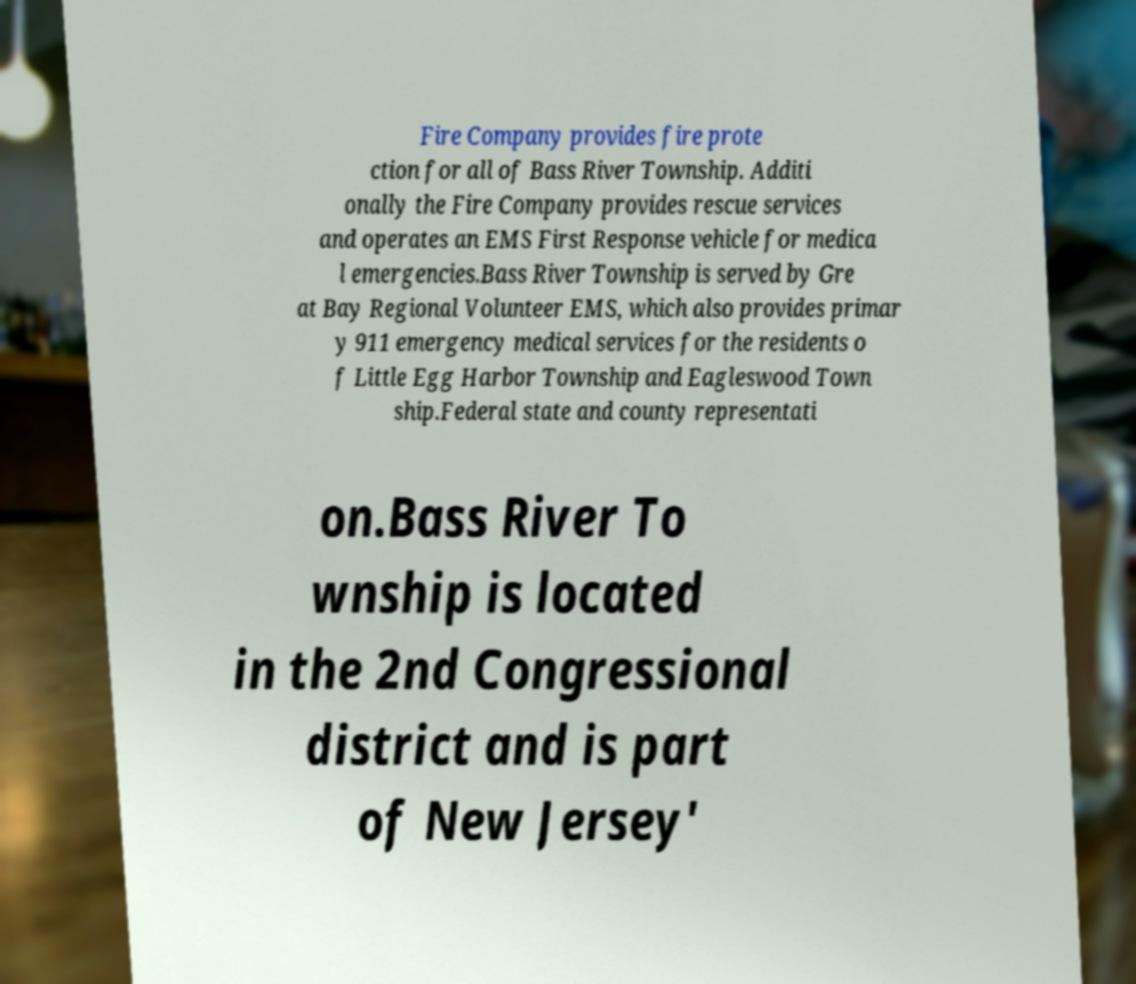Can you read and provide the text displayed in the image?This photo seems to have some interesting text. Can you extract and type it out for me? Fire Company provides fire prote ction for all of Bass River Township. Additi onally the Fire Company provides rescue services and operates an EMS First Response vehicle for medica l emergencies.Bass River Township is served by Gre at Bay Regional Volunteer EMS, which also provides primar y 911 emergency medical services for the residents o f Little Egg Harbor Township and Eagleswood Town ship.Federal state and county representati on.Bass River To wnship is located in the 2nd Congressional district and is part of New Jersey' 